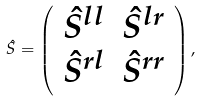<formula> <loc_0><loc_0><loc_500><loc_500>\hat { S } = \left ( \begin{array} { c c } \hat { S } ^ { l l } & \hat { S } ^ { l r } \\ \hat { S } ^ { r l } & \hat { S } ^ { r r } \end{array} \right ) ,</formula> 